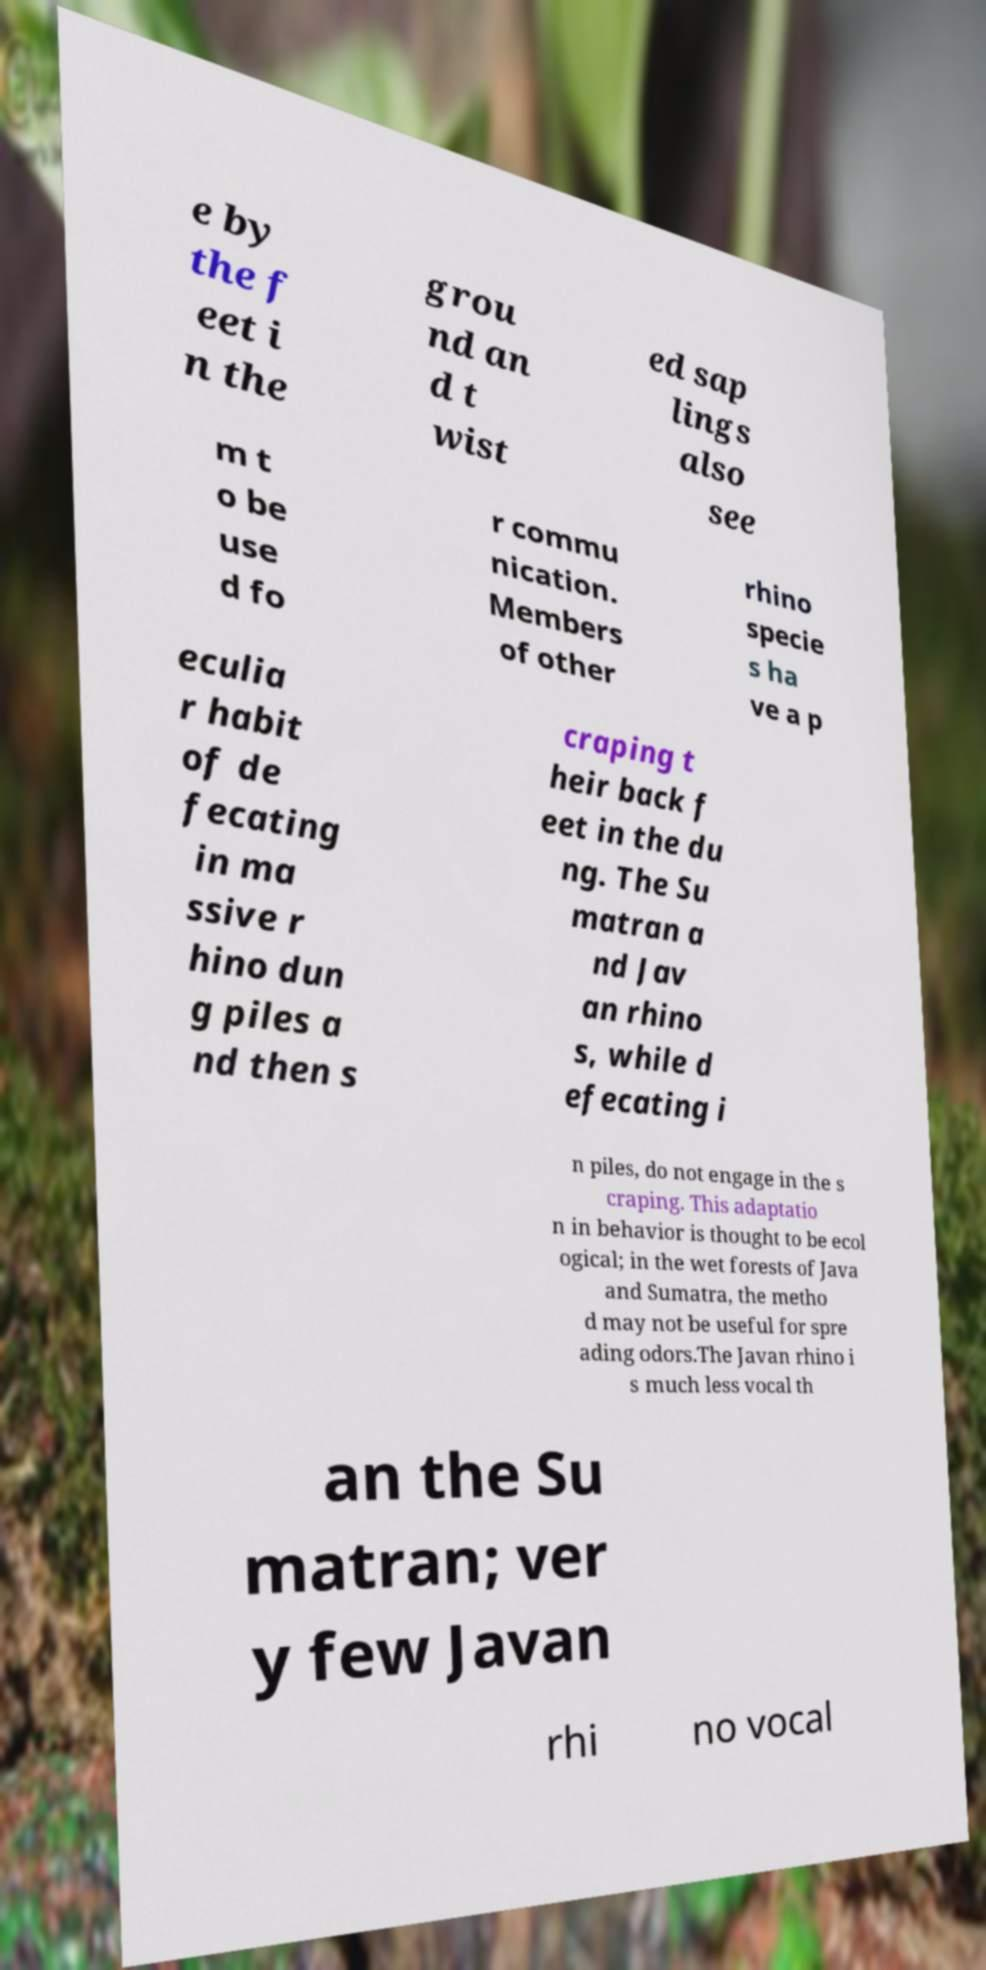Could you assist in decoding the text presented in this image and type it out clearly? e by the f eet i n the grou nd an d t wist ed sap lings also see m t o be use d fo r commu nication. Members of other rhino specie s ha ve a p eculia r habit of de fecating in ma ssive r hino dun g piles a nd then s craping t heir back f eet in the du ng. The Su matran a nd Jav an rhino s, while d efecating i n piles, do not engage in the s craping. This adaptatio n in behavior is thought to be ecol ogical; in the wet forests of Java and Sumatra, the metho d may not be useful for spre ading odors.The Javan rhino i s much less vocal th an the Su matran; ver y few Javan rhi no vocal 